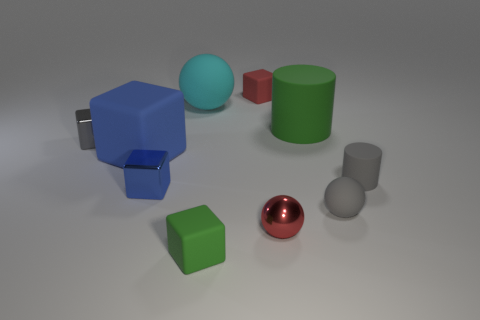Subtract all rubber balls. How many balls are left? 1 Subtract all balls. How many objects are left? 7 Subtract 2 balls. How many balls are left? 1 Subtract all green balls. Subtract all red blocks. How many balls are left? 3 Subtract all brown cylinders. How many gray spheres are left? 1 Subtract all small matte blocks. Subtract all matte cubes. How many objects are left? 5 Add 1 tiny gray cylinders. How many tiny gray cylinders are left? 2 Add 9 small red metal objects. How many small red metal objects exist? 10 Subtract all gray cylinders. How many cylinders are left? 1 Subtract 0 yellow spheres. How many objects are left? 10 